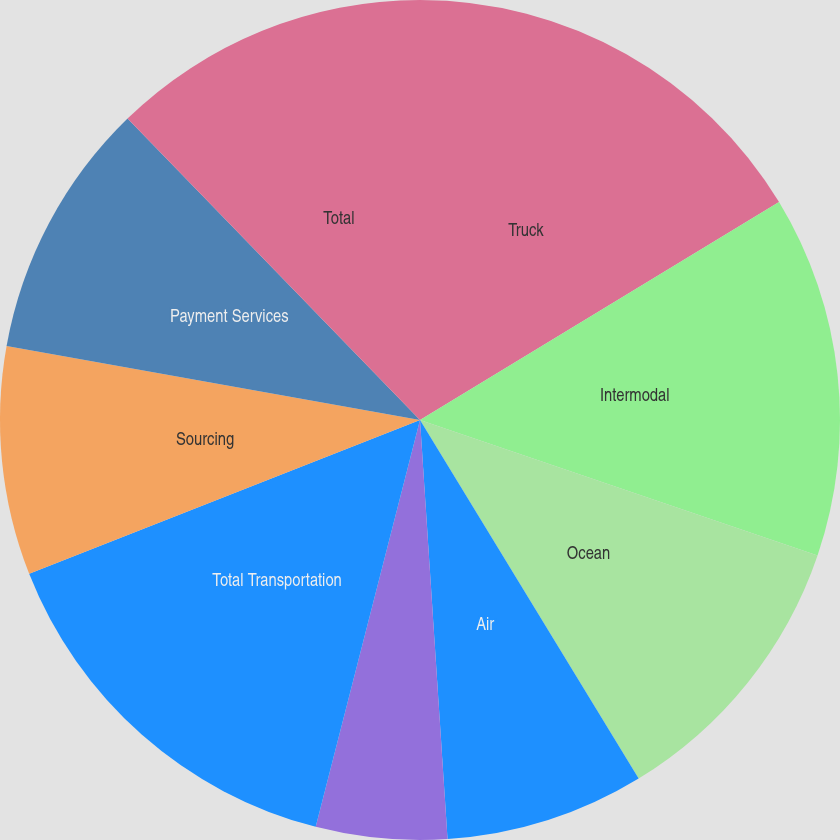Convert chart. <chart><loc_0><loc_0><loc_500><loc_500><pie_chart><fcel>Truck<fcel>Intermodal<fcel>Ocean<fcel>Air<fcel>Other Logistics Services<fcel>Total Transportation<fcel>Sourcing<fcel>Payment Services<fcel>Total<nl><fcel>16.32%<fcel>13.91%<fcel>11.06%<fcel>7.67%<fcel>5.04%<fcel>15.04%<fcel>8.79%<fcel>9.92%<fcel>12.26%<nl></chart> 